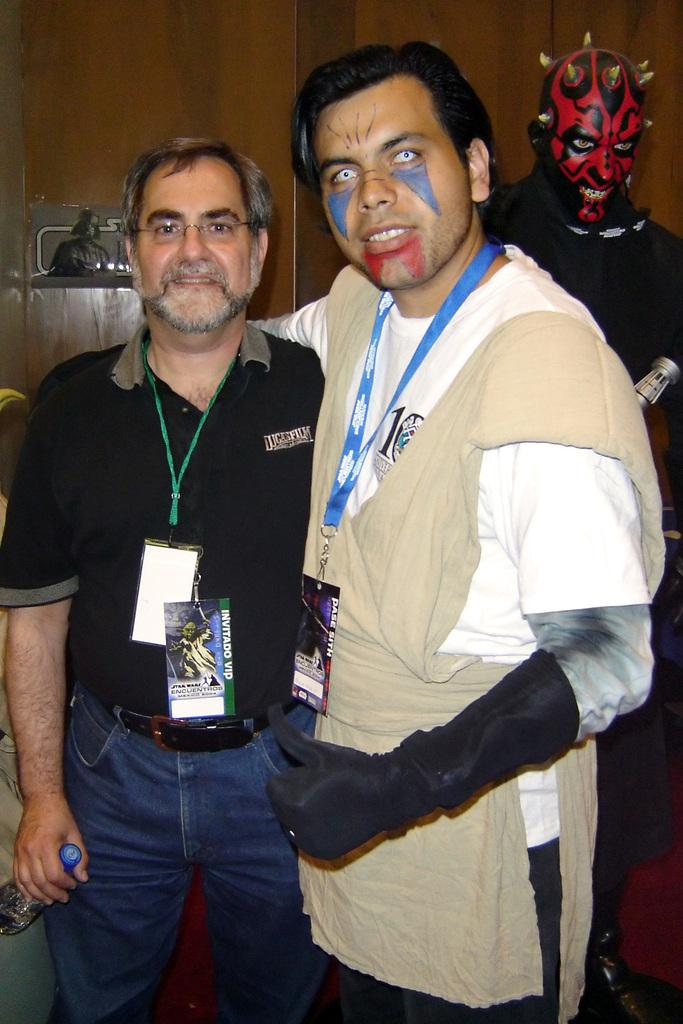How many people are in the image? There are three persons in the image. What is a noticeable feature on some of the persons? Two of the persons have face painting. What can be seen in the background of the image? There is a wall in the background of the image. What type of bulb is hanging from the ceiling in the image? There is no bulb visible in the image; it only features three persons and a wall in the background. 